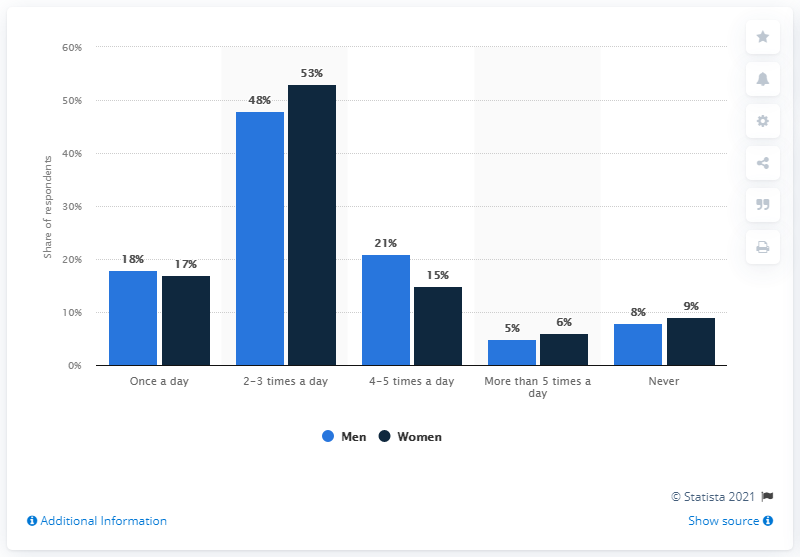Draw attention to some important aspects in this diagram. In the survey of coffee consumption among women, 17% of the respondents reported consuming coffee every day. In how many instances does the light blue bar differ from the dark blue bar by 1 unit? 